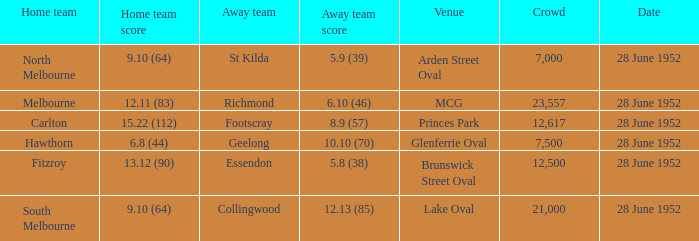What is the home team's score when the venue is princes park? 15.22 (112). 